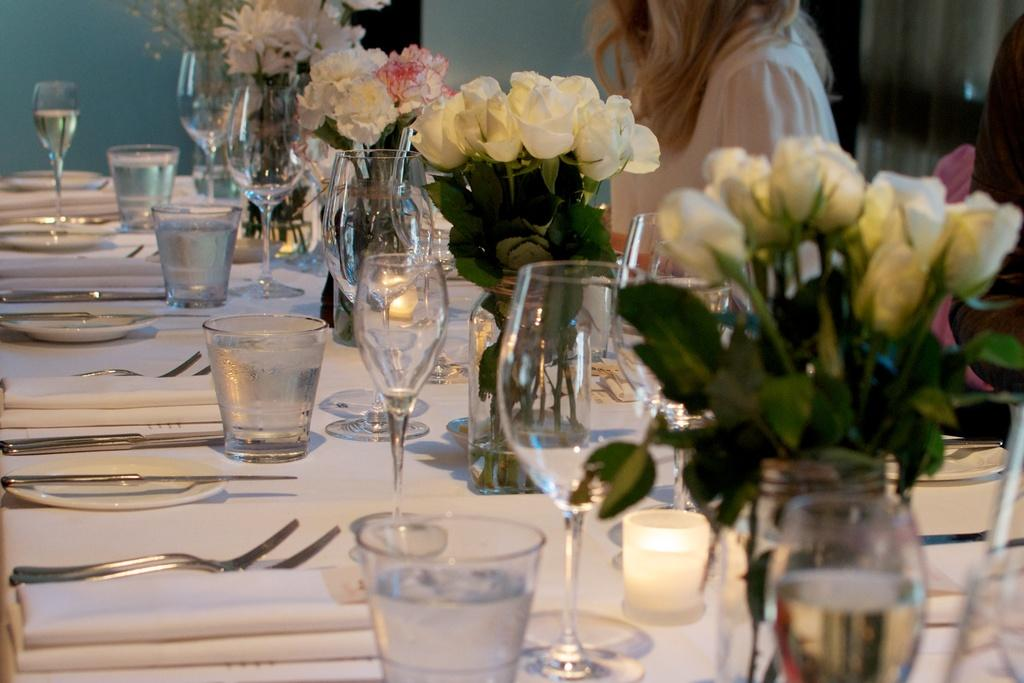What objects are on the table in the image? There is glass, spoons, plates, clothes, and a vase with flowers on the table in the image. What can be used for eating or serving food in the image? Spoons and plates can be used for eating or serving food in the image. What is the decorative item on the table? The vase with flowers in with flowers is the decorative item on the table. Who is present in the image? There is a girl in the image. What hobbies does the moon have in the image? The moon is not present in the image, so it cannot have any hobbies. Can you tell me how many copies of the book are on the table? There is no book mentioned in the image, so it is impossible to determine the number of copies. 